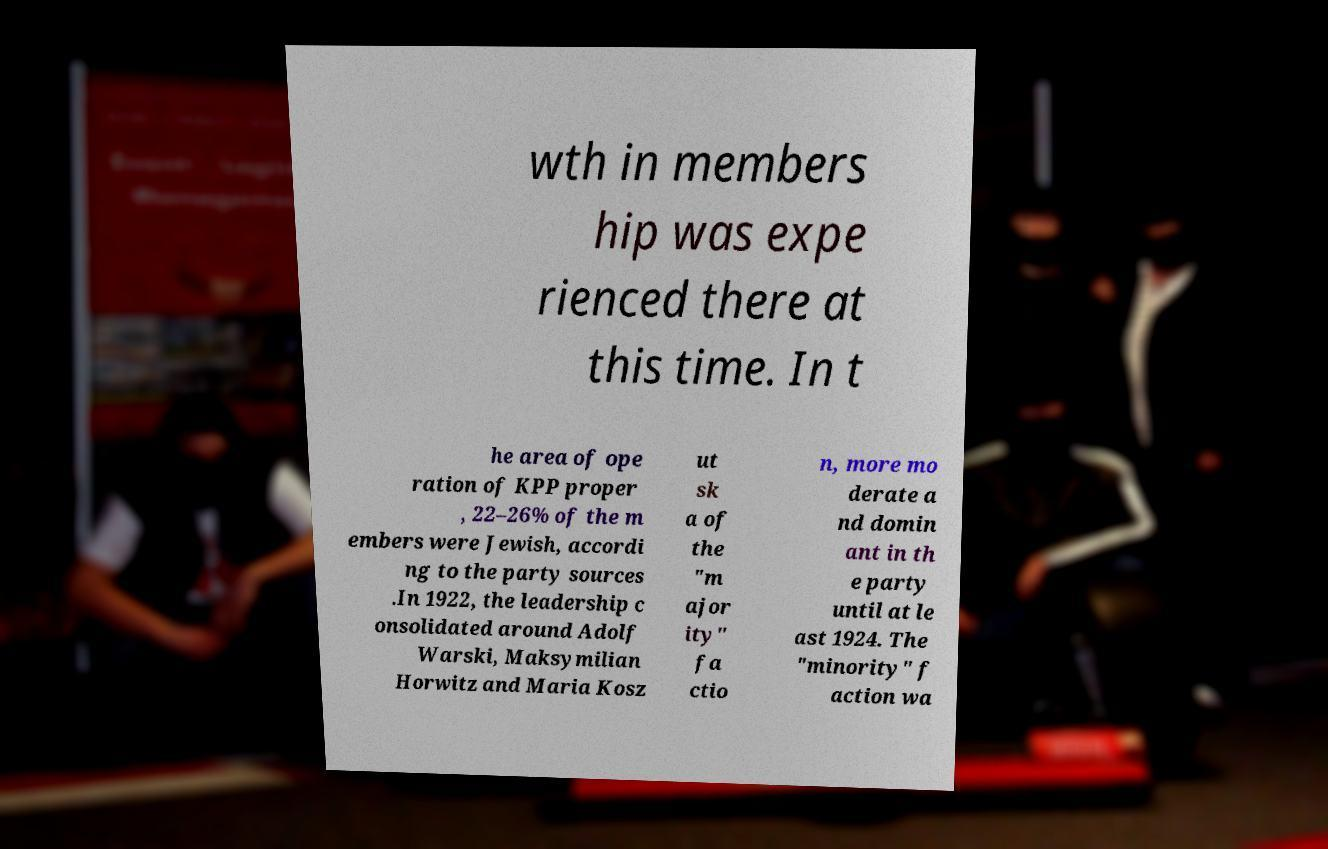For documentation purposes, I need the text within this image transcribed. Could you provide that? wth in members hip was expe rienced there at this time. In t he area of ope ration of KPP proper , 22–26% of the m embers were Jewish, accordi ng to the party sources .In 1922, the leadership c onsolidated around Adolf Warski, Maksymilian Horwitz and Maria Kosz ut sk a of the "m ajor ity" fa ctio n, more mo derate a nd domin ant in th e party until at le ast 1924. The "minority" f action wa 